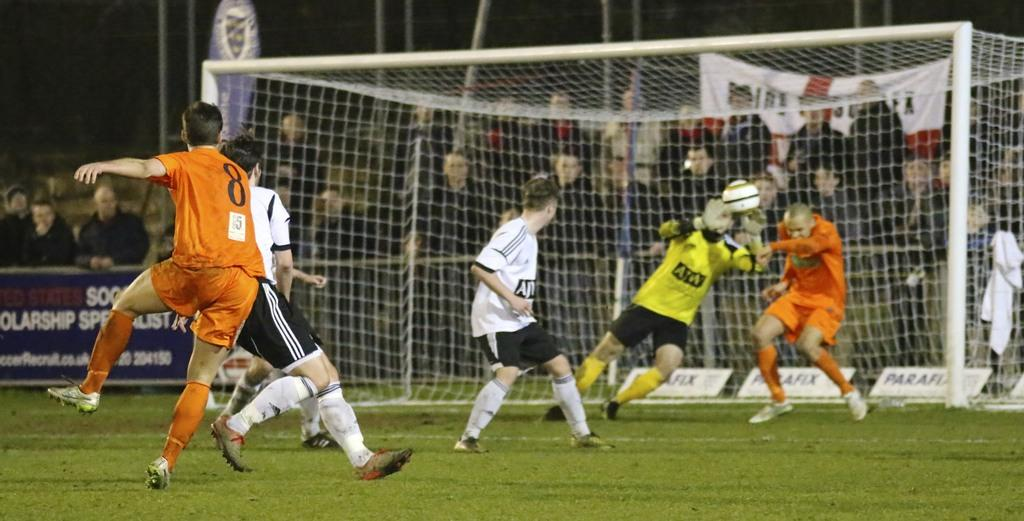Provide a one-sentence caption for the provided image. A soccer player wearing number 8 on the orange team shoots the ball. 